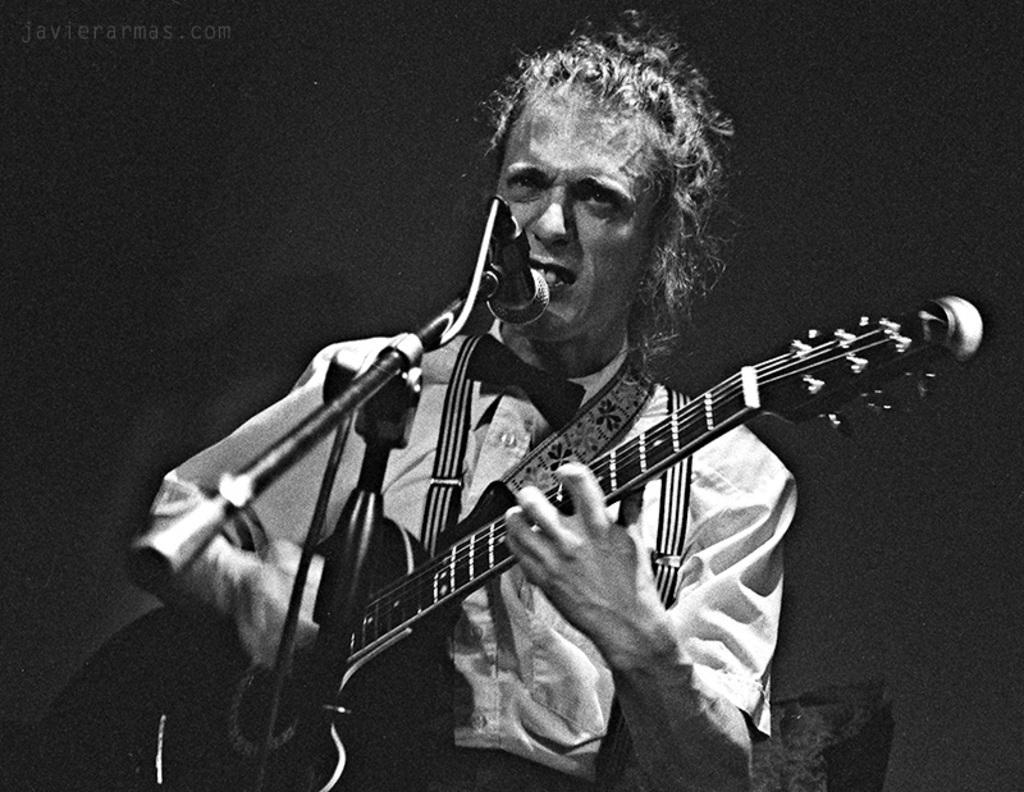Could you give a brief overview of what you see in this image? In the picture, there is a man who is wearing a shirt , a guitar around his shoulders, he is singing a song there is a mike in front of him he is holding guitar with his two hands, the background is plain and empty. 